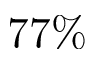<formula> <loc_0><loc_0><loc_500><loc_500>7 7 \%</formula> 